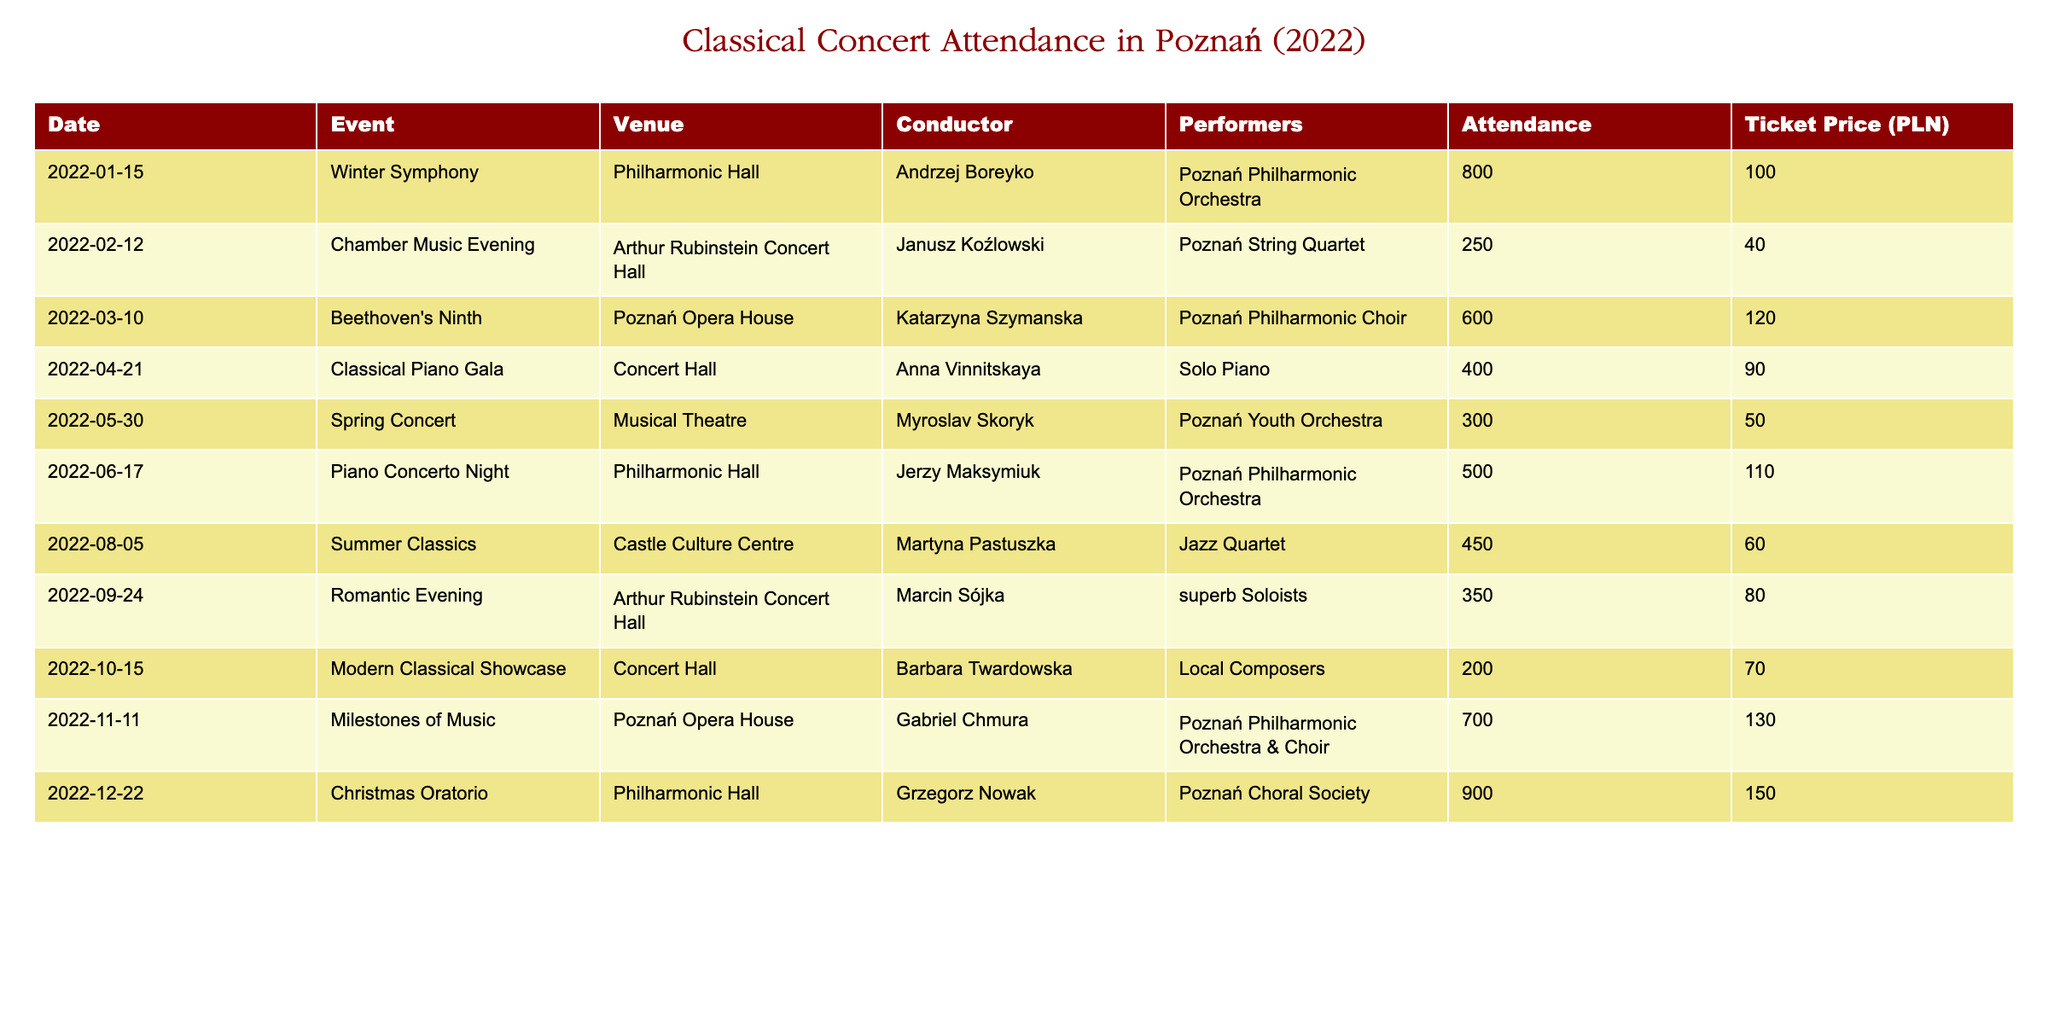What was the attendance for the Christmas Oratorio? The row corresponding to the Christmas Oratorio indicates that the attendance was 900.
Answer: 900 Which concert had the highest ticket price? By comparing the ticket prices listed in the table, the Christmas Oratorio has the highest ticket price at 150 PLN.
Answer: 150 PLN What events took place in the Philharmonic Hall? The events listed in the Philharmonic Hall are the Winter Symphony, Piano Concerto Night, and Christmas Oratorio, which can be found through filtering the Venue column for Philharmonic Hall.
Answer: 3 events What is the average attendance across all concerts? To find the average attendance, first sum all attendances: (800 + 250 + 600 + 400 + 300 + 500 + 450 + 350 + 200 + 700 + 900) = 5150. Then, divide by the number of concerts, which is 11: 5150 / 11 = approximately 468.18.
Answer: 468.18 Did the Spring Concert have a higher attendance than the Modern Classical Showcase? The Spring Concert had an attendance of 300, and the Modern Classical Showcase had an attendance of 200. Since 300 is greater than 200, the Spring Concert had a higher attendance.
Answer: Yes What is the total attendance for concerts held in the second half of the year (July to December)? To find the total attendance for the second half of the year, include the concerts from June to December: (500 + 450 + 350 + 200 + 700 + 900) = 3100.
Answer: 3100 How many concerts had an attendance of more than 600? By reviewing the attendance numbers, the concerts with more than 600 attendees are the Winter Symphony (800), Beethoven's Ninth (600), Milestones of Music (700), and Christmas Oratorio (900). This gives a total of 4 concerts.
Answer: 4 concerts Which conductor had the greatest number of attendees in their concert? The concerts conducted by Grzegorz Nowak (Christmas Oratorio) and Andrzej Boreyko (Winter Symphony) have the highest attendance at 900 and 800 respectively, with Grzegorz Nowak leading with 900.
Answer: Grzegorz Nowak What was the total revenue generated from ticket sales for the entire year? To calculate total revenue, multiply each concert's attendance by its respective ticket price and sum them: (800*100) + (250*40) + (600*120) + (400*90) + (300*50) + (500*110) + (450*60) + (350*80) + (200*70) + (700*130) + (900*150) = 141000 PLN.
Answer: 141000 PLN 